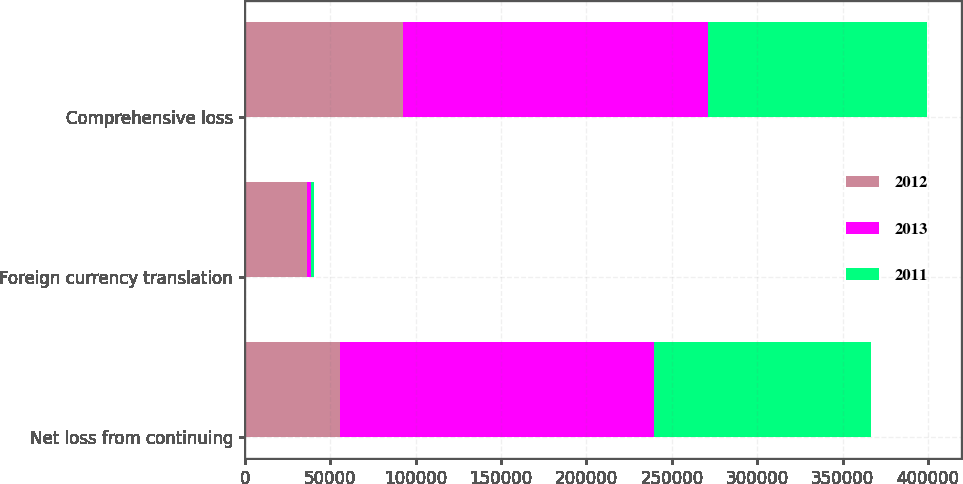Convert chart. <chart><loc_0><loc_0><loc_500><loc_500><stacked_bar_chart><ecel><fcel>Net loss from continuing<fcel>Foreign currency translation<fcel>Comprehensive loss<nl><fcel>2012<fcel>55909<fcel>36470<fcel>92379<nl><fcel>2013<fcel>183686<fcel>2306<fcel>178731<nl><fcel>2011<fcel>126892<fcel>1728<fcel>128184<nl></chart> 